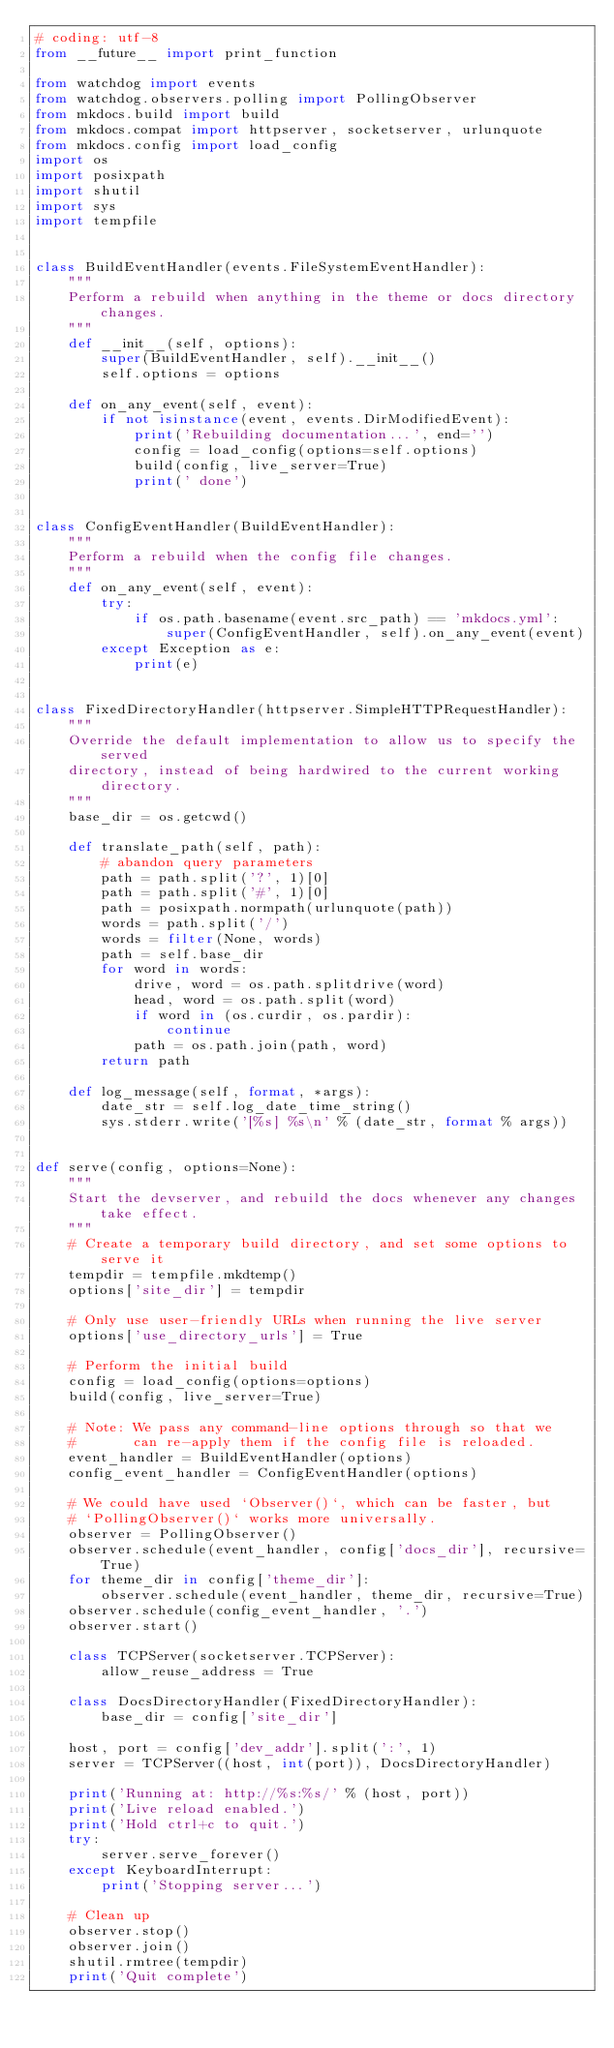Convert code to text. <code><loc_0><loc_0><loc_500><loc_500><_Python_># coding: utf-8
from __future__ import print_function

from watchdog import events
from watchdog.observers.polling import PollingObserver
from mkdocs.build import build
from mkdocs.compat import httpserver, socketserver, urlunquote
from mkdocs.config import load_config
import os
import posixpath
import shutil
import sys
import tempfile


class BuildEventHandler(events.FileSystemEventHandler):
    """
    Perform a rebuild when anything in the theme or docs directory changes.
    """
    def __init__(self, options):
        super(BuildEventHandler, self).__init__()
        self.options = options

    def on_any_event(self, event):
        if not isinstance(event, events.DirModifiedEvent):
            print('Rebuilding documentation...', end='')
            config = load_config(options=self.options)
            build(config, live_server=True)
            print(' done')


class ConfigEventHandler(BuildEventHandler):
    """
    Perform a rebuild when the config file changes.
    """
    def on_any_event(self, event):
        try:
            if os.path.basename(event.src_path) == 'mkdocs.yml':
                super(ConfigEventHandler, self).on_any_event(event)
        except Exception as e:
            print(e)


class FixedDirectoryHandler(httpserver.SimpleHTTPRequestHandler):
    """
    Override the default implementation to allow us to specify the served
    directory, instead of being hardwired to the current working directory.
    """
    base_dir = os.getcwd()

    def translate_path(self, path):
        # abandon query parameters
        path = path.split('?', 1)[0]
        path = path.split('#', 1)[0]
        path = posixpath.normpath(urlunquote(path))
        words = path.split('/')
        words = filter(None, words)
        path = self.base_dir
        for word in words:
            drive, word = os.path.splitdrive(word)
            head, word = os.path.split(word)
            if word in (os.curdir, os.pardir):
                continue
            path = os.path.join(path, word)
        return path

    def log_message(self, format, *args):
        date_str = self.log_date_time_string()
        sys.stderr.write('[%s] %s\n' % (date_str, format % args))


def serve(config, options=None):
    """
    Start the devserver, and rebuild the docs whenever any changes take effect.
    """
    # Create a temporary build directory, and set some options to serve it
    tempdir = tempfile.mkdtemp()
    options['site_dir'] = tempdir

    # Only use user-friendly URLs when running the live server
    options['use_directory_urls'] = True

    # Perform the initial build
    config = load_config(options=options)
    build(config, live_server=True)

    # Note: We pass any command-line options through so that we
    #       can re-apply them if the config file is reloaded.
    event_handler = BuildEventHandler(options)
    config_event_handler = ConfigEventHandler(options)

    # We could have used `Observer()`, which can be faster, but
    # `PollingObserver()` works more universally.
    observer = PollingObserver()
    observer.schedule(event_handler, config['docs_dir'], recursive=True)
    for theme_dir in config['theme_dir']:
        observer.schedule(event_handler, theme_dir, recursive=True)
    observer.schedule(config_event_handler, '.')
    observer.start()

    class TCPServer(socketserver.TCPServer):
        allow_reuse_address = True

    class DocsDirectoryHandler(FixedDirectoryHandler):
        base_dir = config['site_dir']

    host, port = config['dev_addr'].split(':', 1)
    server = TCPServer((host, int(port)), DocsDirectoryHandler)

    print('Running at: http://%s:%s/' % (host, port))
    print('Live reload enabled.')
    print('Hold ctrl+c to quit.')
    try:
        server.serve_forever()
    except KeyboardInterrupt:
        print('Stopping server...')

    # Clean up
    observer.stop()
    observer.join()
    shutil.rmtree(tempdir)
    print('Quit complete')
</code> 